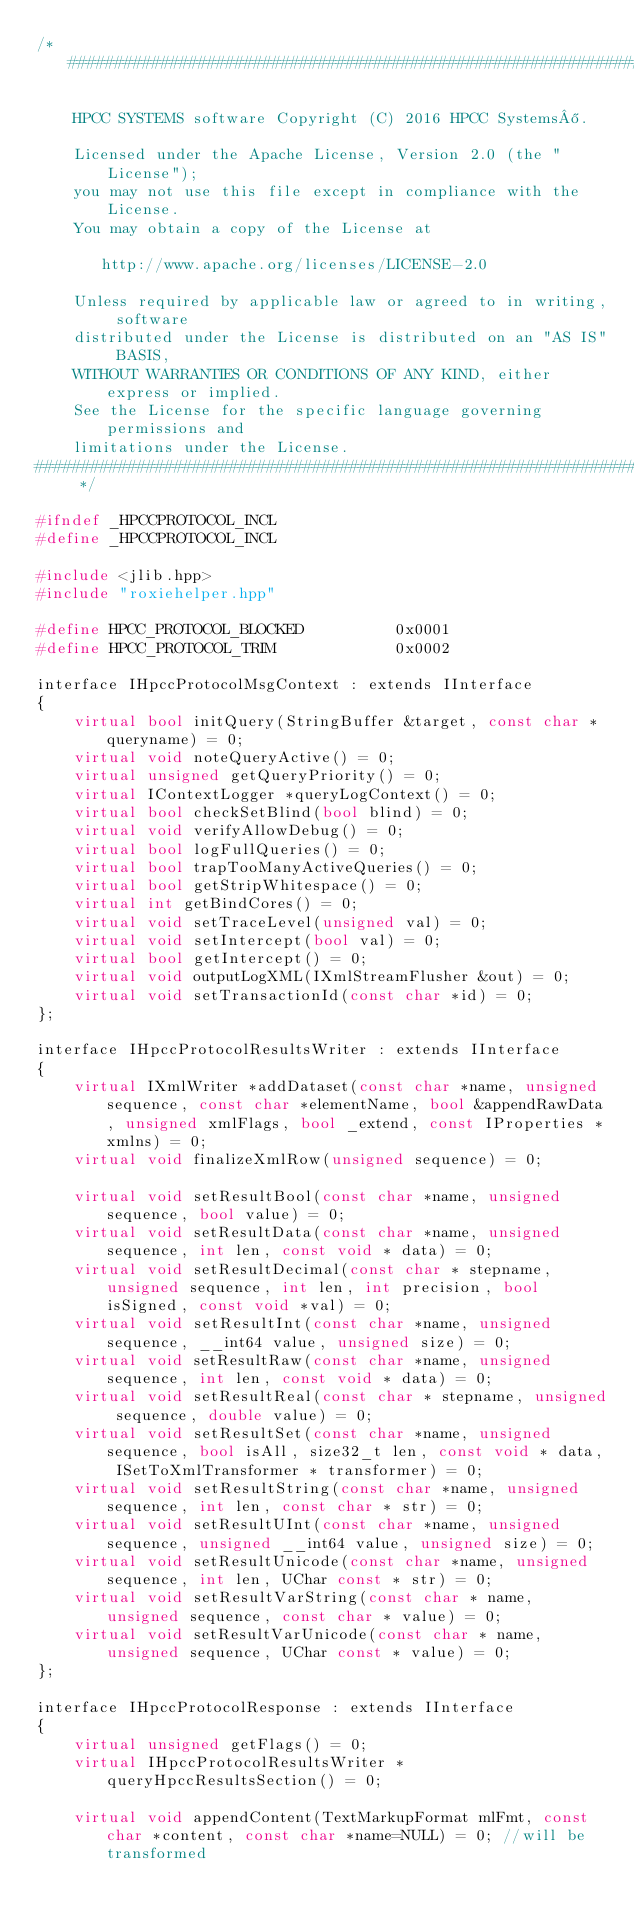<code> <loc_0><loc_0><loc_500><loc_500><_C++_>/*##############################################################################

    HPCC SYSTEMS software Copyright (C) 2016 HPCC Systems®.

    Licensed under the Apache License, Version 2.0 (the "License");
    you may not use this file except in compliance with the License.
    You may obtain a copy of the License at

       http://www.apache.org/licenses/LICENSE-2.0

    Unless required by applicable law or agreed to in writing, software
    distributed under the License is distributed on an "AS IS" BASIS,
    WITHOUT WARRANTIES OR CONDITIONS OF ANY KIND, either express or implied.
    See the License for the specific language governing permissions and
    limitations under the License.
############################################################################## */

#ifndef _HPCCPROTOCOL_INCL
#define _HPCCPROTOCOL_INCL

#include <jlib.hpp>
#include "roxiehelper.hpp"

#define HPCC_PROTOCOL_BLOCKED          0x0001
#define HPCC_PROTOCOL_TRIM             0x0002

interface IHpccProtocolMsgContext : extends IInterface
{
    virtual bool initQuery(StringBuffer &target, const char *queryname) = 0;
    virtual void noteQueryActive() = 0;
    virtual unsigned getQueryPriority() = 0;
    virtual IContextLogger *queryLogContext() = 0;
    virtual bool checkSetBlind(bool blind) = 0;
    virtual void verifyAllowDebug() = 0;
    virtual bool logFullQueries() = 0;
    virtual bool trapTooManyActiveQueries() = 0;
    virtual bool getStripWhitespace() = 0;
    virtual int getBindCores() = 0;
    virtual void setTraceLevel(unsigned val) = 0;
    virtual void setIntercept(bool val) = 0;
    virtual bool getIntercept() = 0;
    virtual void outputLogXML(IXmlStreamFlusher &out) = 0;
    virtual void setTransactionId(const char *id) = 0;
};

interface IHpccProtocolResultsWriter : extends IInterface
{
    virtual IXmlWriter *addDataset(const char *name, unsigned sequence, const char *elementName, bool &appendRawData, unsigned xmlFlags, bool _extend, const IProperties *xmlns) = 0;
    virtual void finalizeXmlRow(unsigned sequence) = 0;

    virtual void setResultBool(const char *name, unsigned sequence, bool value) = 0;
    virtual void setResultData(const char *name, unsigned sequence, int len, const void * data) = 0;
    virtual void setResultDecimal(const char * stepname, unsigned sequence, int len, int precision, bool isSigned, const void *val) = 0;
    virtual void setResultInt(const char *name, unsigned sequence, __int64 value, unsigned size) = 0;
    virtual void setResultRaw(const char *name, unsigned sequence, int len, const void * data) = 0;
    virtual void setResultReal(const char * stepname, unsigned sequence, double value) = 0;
    virtual void setResultSet(const char *name, unsigned sequence, bool isAll, size32_t len, const void * data, ISetToXmlTransformer * transformer) = 0;
    virtual void setResultString(const char *name, unsigned sequence, int len, const char * str) = 0;
    virtual void setResultUInt(const char *name, unsigned sequence, unsigned __int64 value, unsigned size) = 0;
    virtual void setResultUnicode(const char *name, unsigned sequence, int len, UChar const * str) = 0;
    virtual void setResultVarString(const char * name, unsigned sequence, const char * value) = 0;
    virtual void setResultVarUnicode(const char * name, unsigned sequence, UChar const * value) = 0;
};

interface IHpccProtocolResponse : extends IInterface
{
    virtual unsigned getFlags() = 0;
    virtual IHpccProtocolResultsWriter *queryHpccResultsSection() = 0;

    virtual void appendContent(TextMarkupFormat mlFmt, const char *content, const char *name=NULL) = 0; //will be transformed</code> 